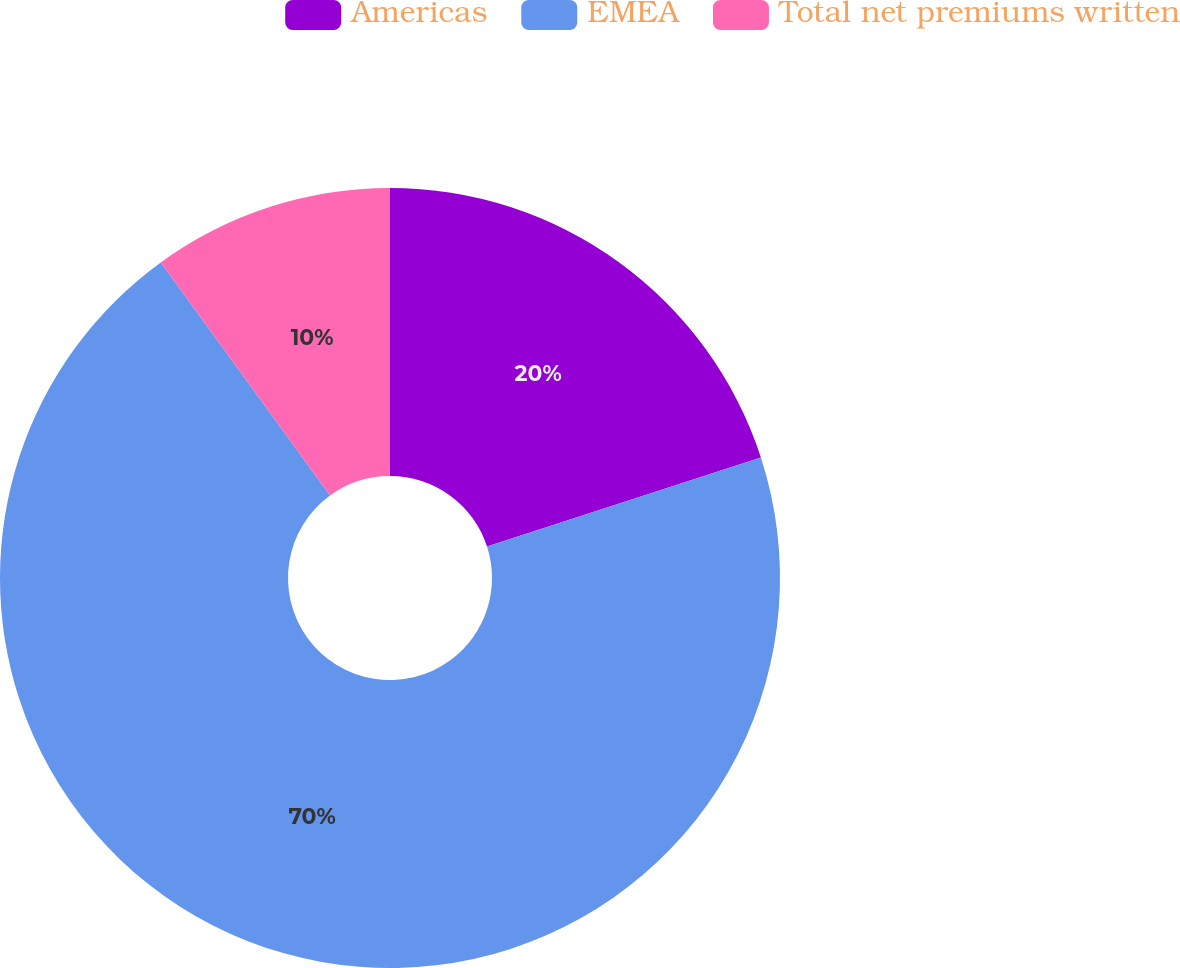<chart> <loc_0><loc_0><loc_500><loc_500><pie_chart><fcel>Americas<fcel>EMEA<fcel>Total net premiums written<nl><fcel>20.0%<fcel>70.0%<fcel>10.0%<nl></chart> 